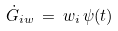<formula> <loc_0><loc_0><loc_500><loc_500>\dot { G } _ { i w } \, = \, w _ { i } \, \psi ( t )</formula> 